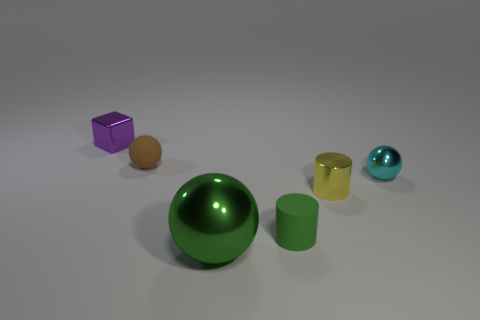Add 3 cyan metallic balls. How many objects exist? 9 Subtract all cylinders. How many objects are left? 4 Subtract 0 blue cylinders. How many objects are left? 6 Subtract all big objects. Subtract all tiny spheres. How many objects are left? 3 Add 2 tiny cyan shiny balls. How many tiny cyan shiny balls are left? 3 Add 5 cyan balls. How many cyan balls exist? 6 